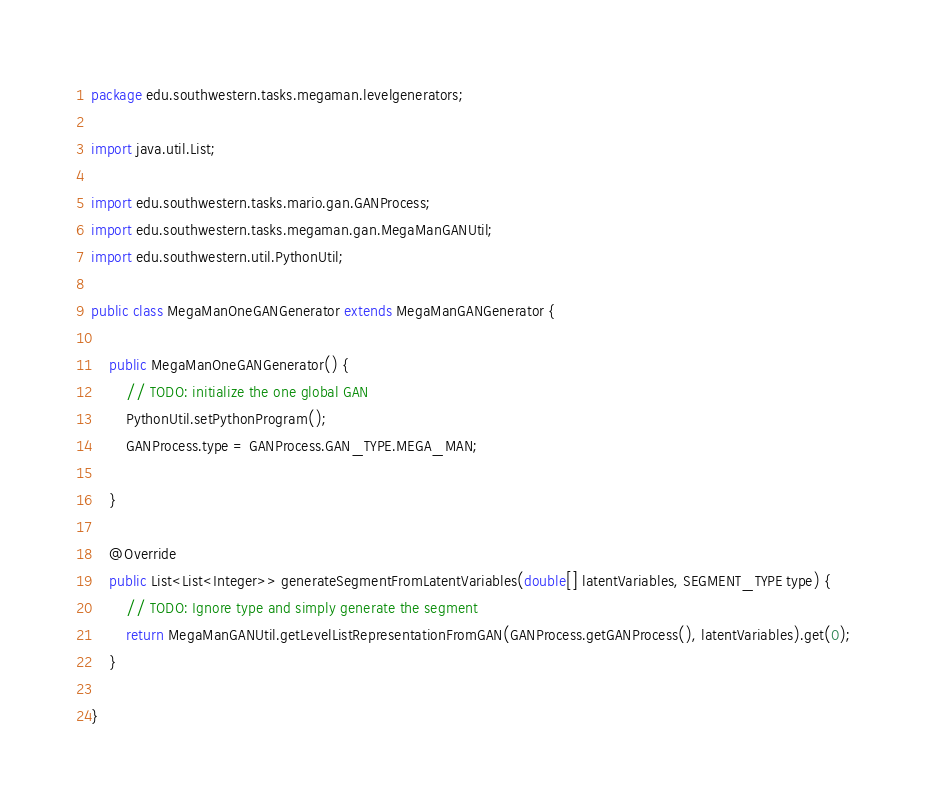<code> <loc_0><loc_0><loc_500><loc_500><_Java_>package edu.southwestern.tasks.megaman.levelgenerators;

import java.util.List;

import edu.southwestern.tasks.mario.gan.GANProcess;
import edu.southwestern.tasks.megaman.gan.MegaManGANUtil;
import edu.southwestern.util.PythonUtil;

public class MegaManOneGANGenerator extends MegaManGANGenerator {

	public MegaManOneGANGenerator() {
		// TODO: initialize the one global GAN
		PythonUtil.setPythonProgram();
		GANProcess.type = GANProcess.GAN_TYPE.MEGA_MAN;
	
	}
	
	@Override
	public List<List<Integer>> generateSegmentFromLatentVariables(double[] latentVariables, SEGMENT_TYPE type) {
		// TODO: Ignore type and simply generate the segment
		return MegaManGANUtil.getLevelListRepresentationFromGAN(GANProcess.getGANProcess(), latentVariables).get(0);
	}

}
</code> 